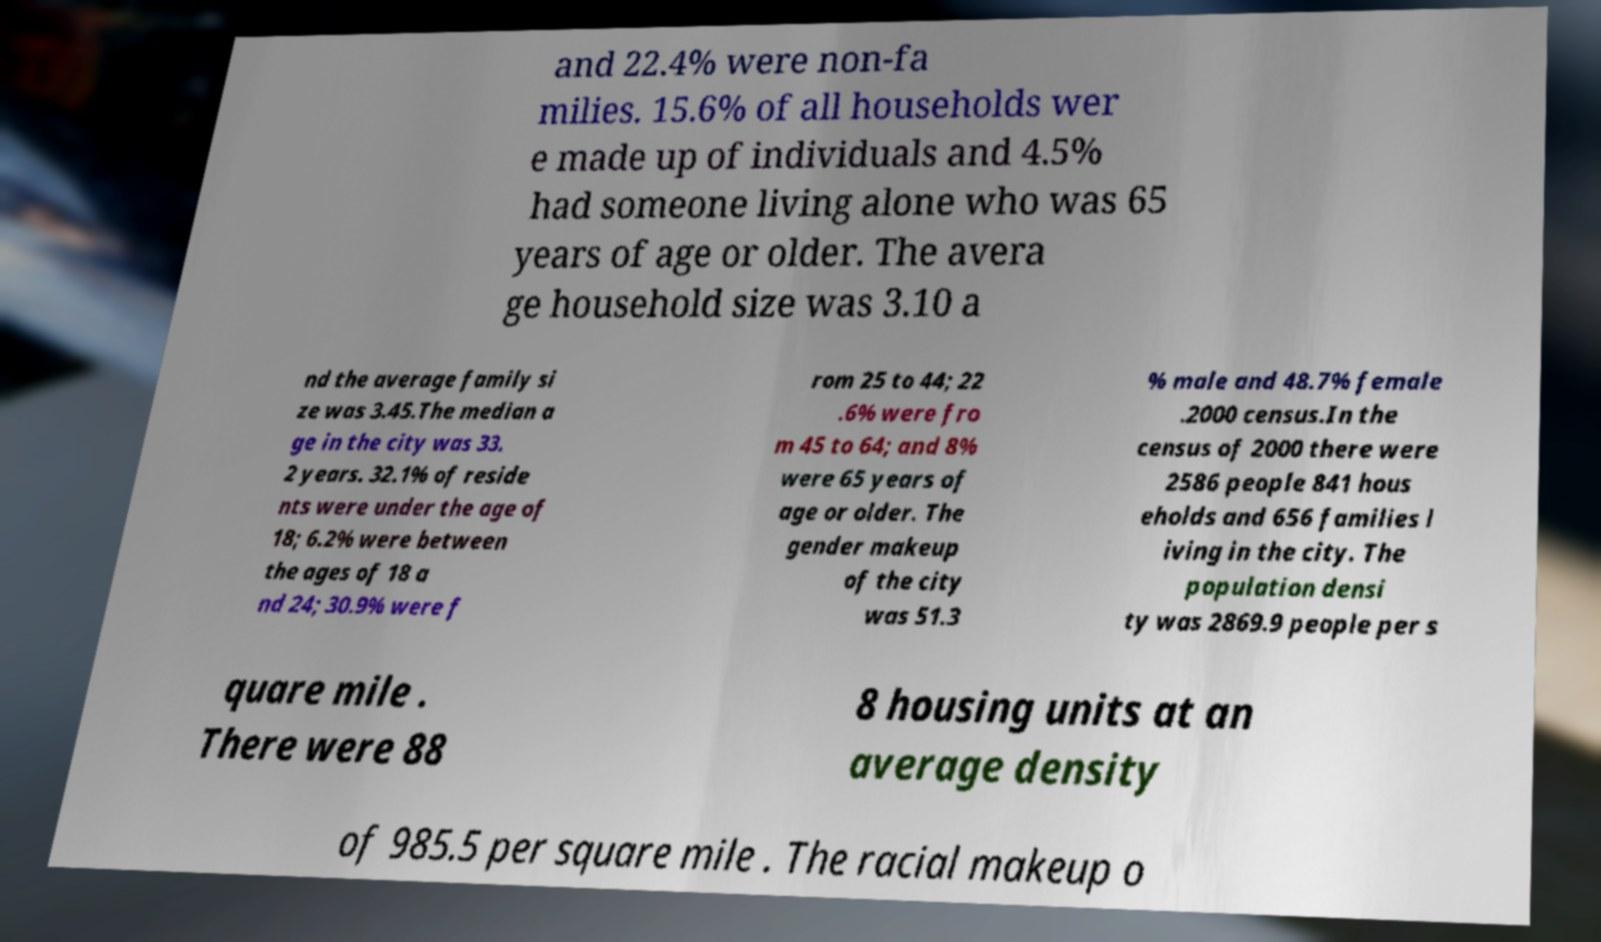For documentation purposes, I need the text within this image transcribed. Could you provide that? and 22.4% were non-fa milies. 15.6% of all households wer e made up of individuals and 4.5% had someone living alone who was 65 years of age or older. The avera ge household size was 3.10 a nd the average family si ze was 3.45.The median a ge in the city was 33. 2 years. 32.1% of reside nts were under the age of 18; 6.2% were between the ages of 18 a nd 24; 30.9% were f rom 25 to 44; 22 .6% were fro m 45 to 64; and 8% were 65 years of age or older. The gender makeup of the city was 51.3 % male and 48.7% female .2000 census.In the census of 2000 there were 2586 people 841 hous eholds and 656 families l iving in the city. The population densi ty was 2869.9 people per s quare mile . There were 88 8 housing units at an average density of 985.5 per square mile . The racial makeup o 